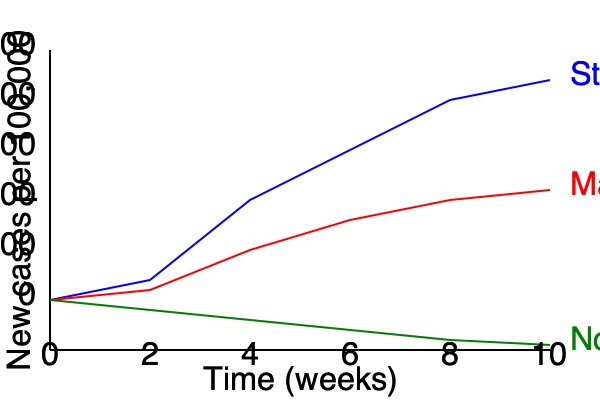The graph shows the progression of new COVID-19 cases per 100,000 people over 10 weeks under different containment measures. Calculate the approximate reduction in new cases achieved by implementing strict lockdown measures compared to no measures at week 10. Express your answer as a percentage. To solve this problem, we need to follow these steps:

1. Identify the number of new cases per 100,000 people at week 10 for both strict lockdown and no measures:
   - Strict lockdown (blue line): approximately 80 cases per 100,000
   - No measures (green line): approximately 345 cases per 100,000

2. Calculate the difference in cases between the two scenarios:
   $345 - 80 = 265$ cases per 100,000

3. Calculate the percentage reduction:
   Percentage reduction = $\frac{\text{Difference in cases}}{\text{Cases with no measures}} \times 100\%$
   
   $= \frac{265}{345} \times 100\%$
   
   $\approx 0.7681 \times 100\%$
   
   $\approx 76.81\%$

4. Round to the nearest whole percentage:
   $76.81\% \approx 77\%$

Thus, the strict lockdown measures resulted in approximately a 77% reduction in new cases compared to no measures at week 10.
Answer: 77% 